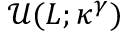<formula> <loc_0><loc_0><loc_500><loc_500>\mathcal { U } ( L ; \kappa ^ { \gamma } )</formula> 